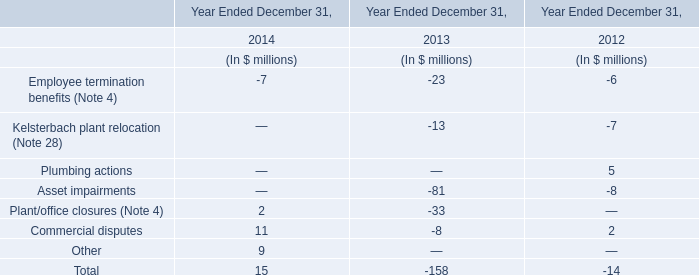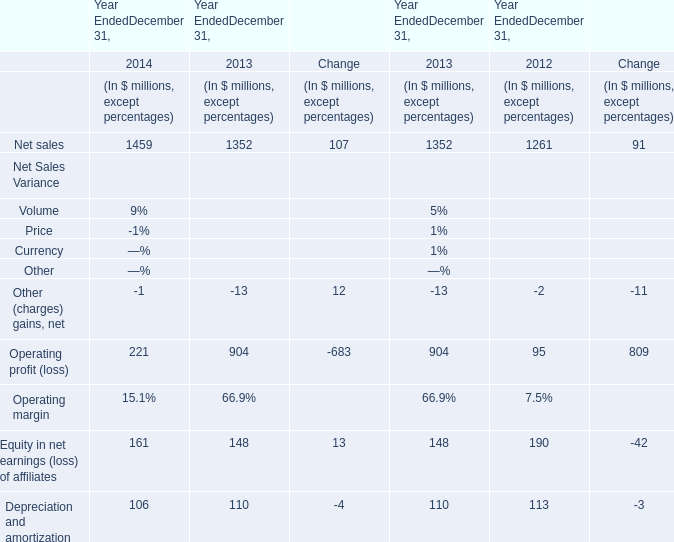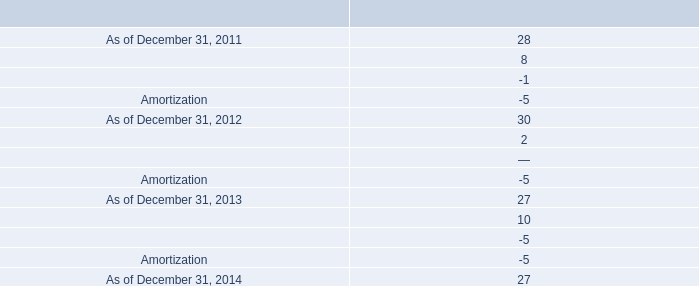assuming the revolver is undrawn , what would the annual fee for the revolver be? 
Computations: ((900 * 0.25%) * 1000000)
Answer: 2250000.0. 